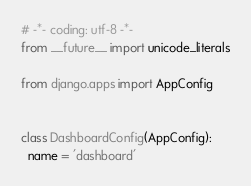Convert code to text. <code><loc_0><loc_0><loc_500><loc_500><_Python_># -*- coding: utf-8 -*-
from __future__ import unicode_literals

from django.apps import AppConfig


class DashboardConfig(AppConfig):
  name = 'dashboard'
</code> 